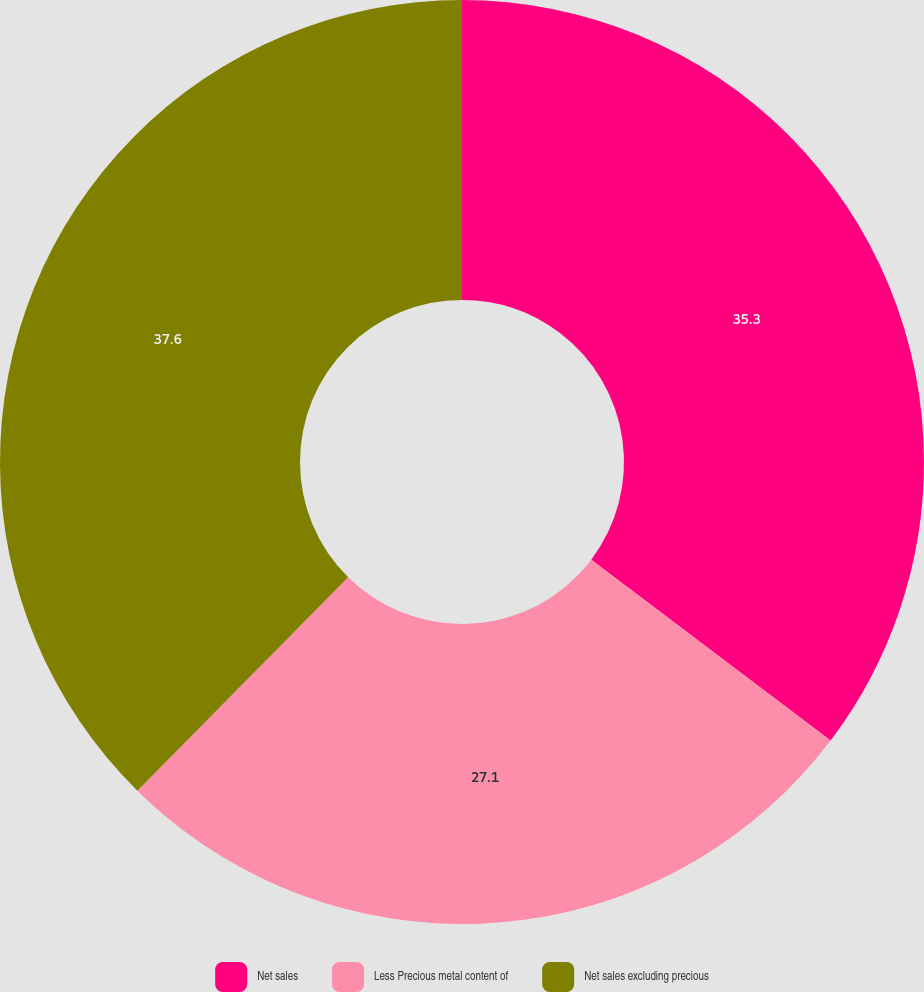Convert chart to OTSL. <chart><loc_0><loc_0><loc_500><loc_500><pie_chart><fcel>Net sales<fcel>Less Precious metal content of<fcel>Net sales excluding precious<nl><fcel>35.3%<fcel>27.1%<fcel>37.6%<nl></chart> 